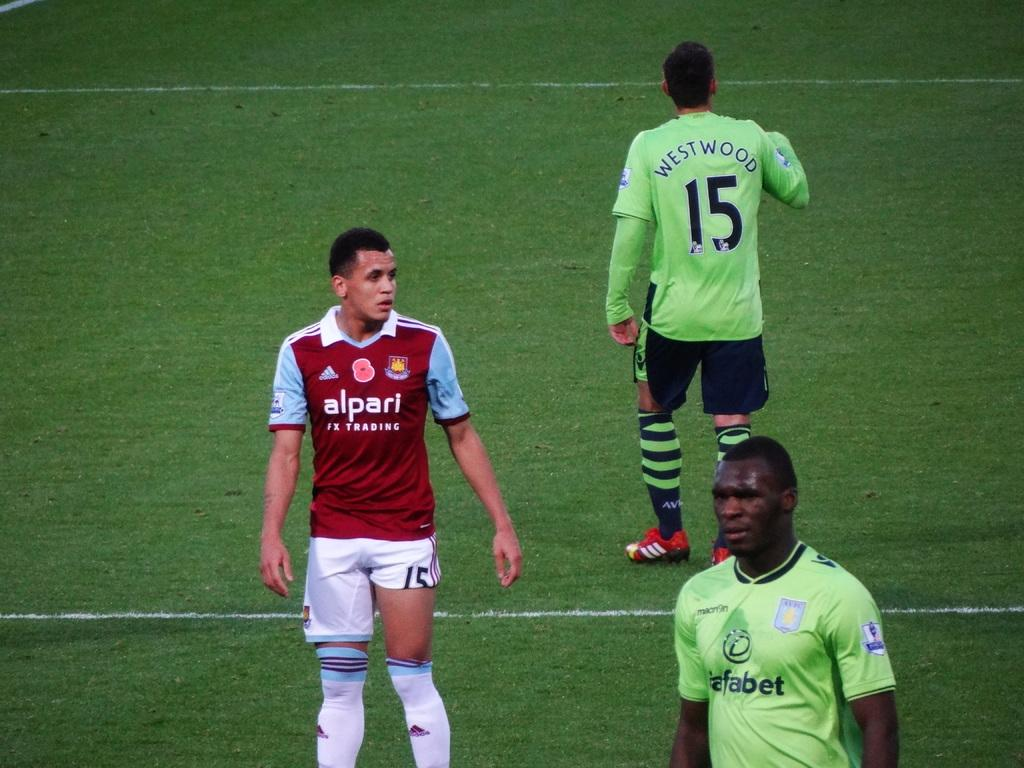Provide a one-sentence caption for the provided image. 3 soccer players can be seen, with 15 facing away from the camera. 